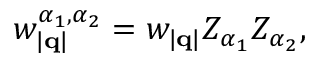<formula> <loc_0><loc_0><loc_500><loc_500>w _ { | q | } ^ { \alpha _ { 1 } , \alpha _ { 2 } } = w _ { | q | } Z _ { \alpha _ { 1 } } Z _ { \alpha _ { 2 } } ,</formula> 